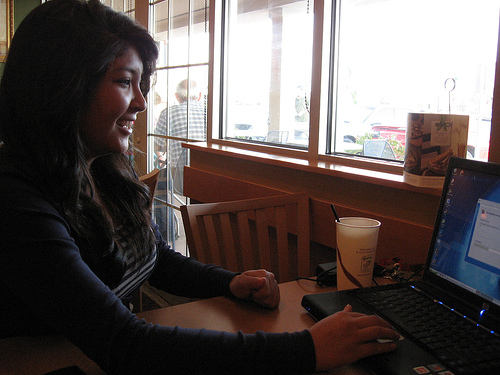<image>
Is the woman above the computer? No. The woman is not positioned above the computer. The vertical arrangement shows a different relationship. Is there a woman in front of the building? No. The woman is not in front of the building. The spatial positioning shows a different relationship between these objects. 